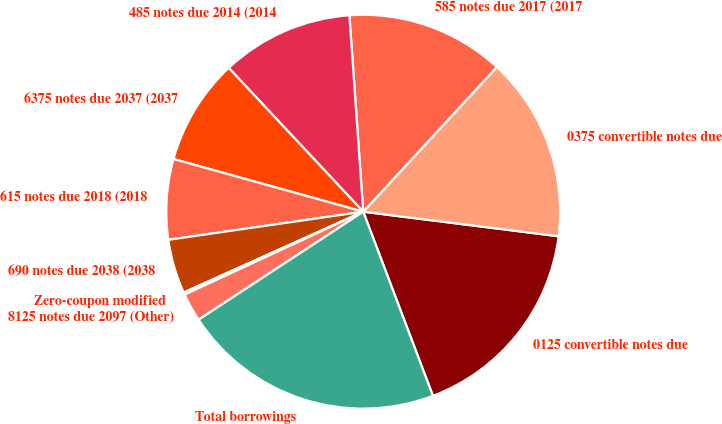Convert chart. <chart><loc_0><loc_0><loc_500><loc_500><pie_chart><fcel>0125 convertible notes due<fcel>0375 convertible notes due<fcel>585 notes due 2017 (2017<fcel>485 notes due 2014 (2014<fcel>6375 notes due 2037 (2037<fcel>615 notes due 2018 (2018<fcel>690 notes due 2038 (2038<fcel>Zero-coupon modified<fcel>8125 notes due 2097 (Other)<fcel>Total borrowings<nl><fcel>17.25%<fcel>15.12%<fcel>12.99%<fcel>10.85%<fcel>8.72%<fcel>6.59%<fcel>4.45%<fcel>0.19%<fcel>2.32%<fcel>21.52%<nl></chart> 